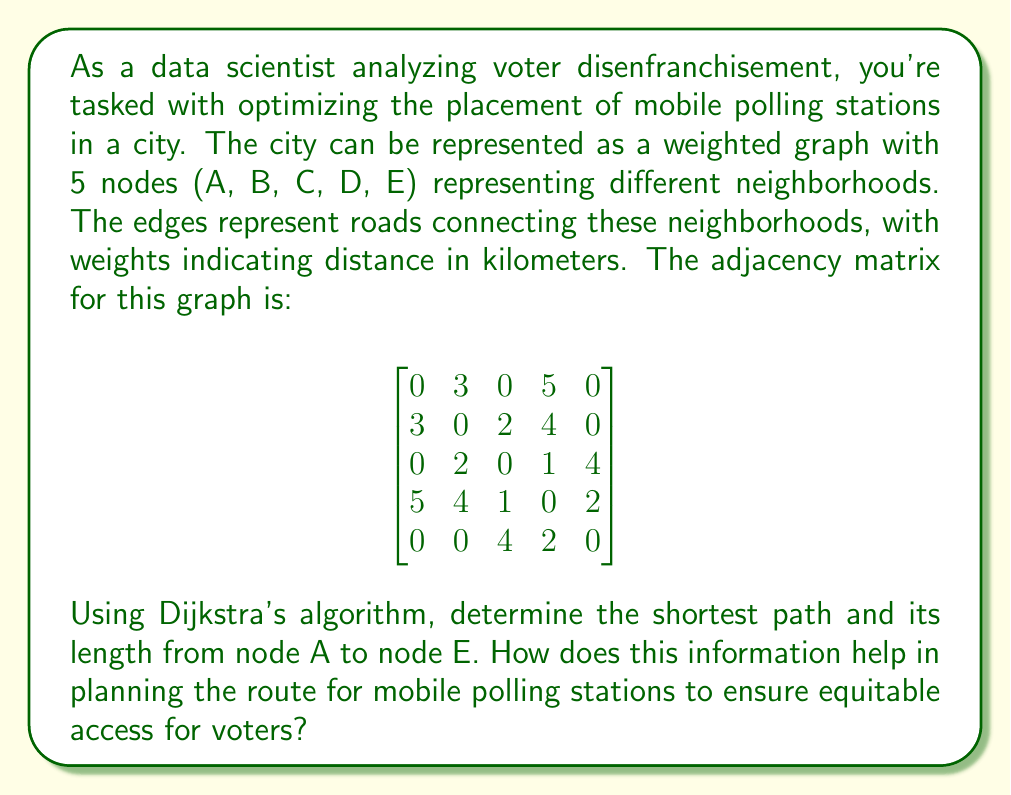Give your solution to this math problem. To solve this problem, we'll use Dijkstra's algorithm to find the shortest path from node A to node E. Here's a step-by-step explanation:

1) Initialize:
   - Distance to A = 0
   - Distance to all other nodes = infinity
   - Previous node for all nodes = undefined
   - Unvisited set = {A, B, C, D, E}

2) Start from node A:
   - Update distances: B = 3, D = 5
   - Mark A as visited
   - Unvisited set = {B, C, D, E}

3) Select B (shortest distance from A):
   - Update distances: C = 5 (3 + 2)
   - Mark B as visited
   - Unvisited set = {C, D, E}

4) Select D (shortest distance from A):
   - Update distances: C = 4 (1 + 3), E = 7 (5 + 2)
   - Mark D as visited
   - Unvisited set = {C, E}

5) Select C:
   - No updates needed
   - Mark C as visited
   - Unvisited set = {E}

6) Select E:
   - Algorithm complete

The shortest path from A to E is A -> D -> E, with a total distance of 7 km.

[asy]
unitsize(30);
pair A = (0,0), B = (1,1), C = (2,0), D = (1,-1), E = (2,-1);
draw(A--B--C--D--E);
draw(A--D);
label("A", A, W);
label("B", B, N);
label("C", C, N);
label("D", D, S);
label("E", E, E);
label("3", (A+B)/2, NW);
label("2", (B+C)/2, N);
label("4", (B+D)/2, SE);
label("5", (A+D)/2, SW);
label("1", (C+D)/2, E);
label("2", (D+E)/2, S);
draw(A--D--E, red+1);
[/asy]

This information helps in planning the route for mobile polling stations by:

1) Identifying the most efficient route to reach all neighborhoods, minimizing travel time and resources.
2) Ensuring equitable access by understanding the minimum distance voters in each neighborhood need to travel.
3) Highlighting potential areas where additional polling stations might be needed if the shortest path is still too long for some voters.
4) Allowing for the creation of a schedule that can reach all neighborhoods in the most time-efficient manner.
5) Providing a basis for further analysis, such as comparing this optimal route with demographic data to identify potential disparities in voting access.
Answer: The shortest path from A to E is A -> D -> E, with a total length of 7 km. 